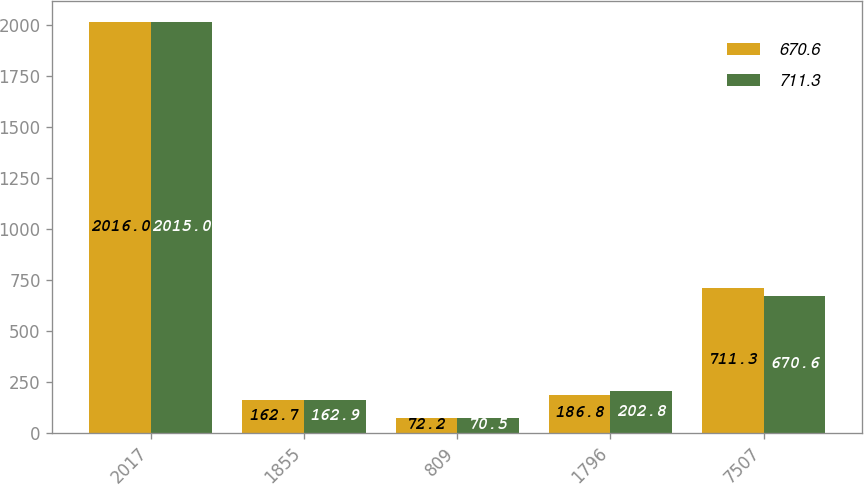<chart> <loc_0><loc_0><loc_500><loc_500><stacked_bar_chart><ecel><fcel>2017<fcel>1855<fcel>809<fcel>1796<fcel>7507<nl><fcel>670.6<fcel>2016<fcel>162.7<fcel>72.2<fcel>186.8<fcel>711.3<nl><fcel>711.3<fcel>2015<fcel>162.9<fcel>70.5<fcel>202.8<fcel>670.6<nl></chart> 